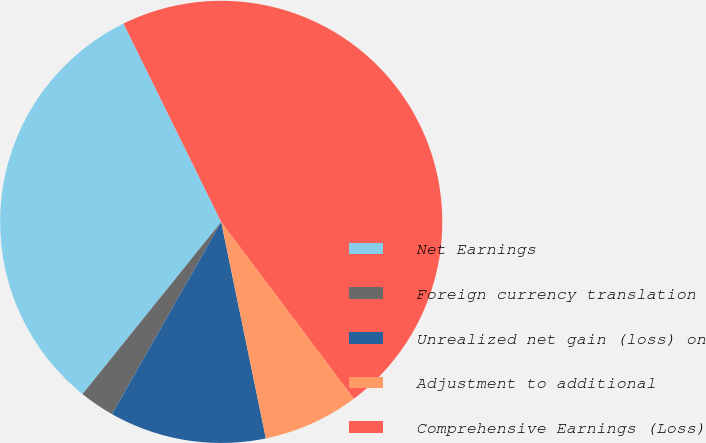Convert chart. <chart><loc_0><loc_0><loc_500><loc_500><pie_chart><fcel>Net Earnings<fcel>Foreign currency translation<fcel>Unrealized net gain (loss) on<fcel>Adjustment to additional<fcel>Comprehensive Earnings (Loss)<nl><fcel>31.92%<fcel>2.57%<fcel>11.46%<fcel>7.01%<fcel>47.03%<nl></chart> 